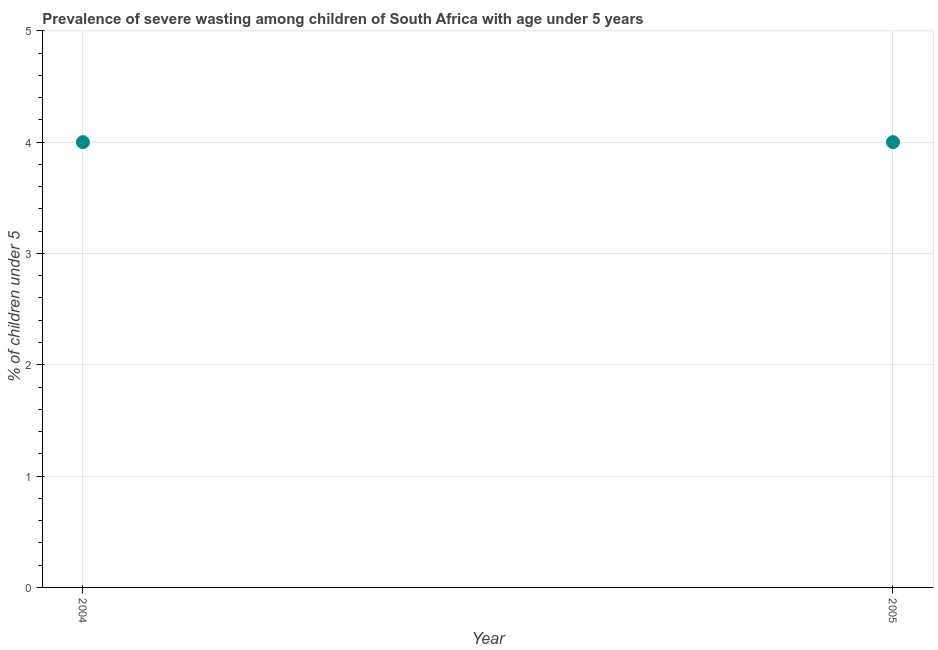What is the prevalence of severe wasting in 2005?
Keep it short and to the point. 4. Across all years, what is the maximum prevalence of severe wasting?
Your answer should be very brief. 4. Across all years, what is the minimum prevalence of severe wasting?
Provide a short and direct response. 4. In which year was the prevalence of severe wasting maximum?
Your response must be concise. 2004. What is the sum of the prevalence of severe wasting?
Provide a short and direct response. 8. What is the average prevalence of severe wasting per year?
Offer a very short reply. 4. What is the median prevalence of severe wasting?
Keep it short and to the point. 4. Do a majority of the years between 2005 and 2004 (inclusive) have prevalence of severe wasting greater than 1.6 %?
Give a very brief answer. No. What is the ratio of the prevalence of severe wasting in 2004 to that in 2005?
Provide a succinct answer. 1. Is the prevalence of severe wasting in 2004 less than that in 2005?
Ensure brevity in your answer.  No. In how many years, is the prevalence of severe wasting greater than the average prevalence of severe wasting taken over all years?
Provide a short and direct response. 0. Are the values on the major ticks of Y-axis written in scientific E-notation?
Provide a short and direct response. No. Does the graph contain grids?
Ensure brevity in your answer.  Yes. What is the title of the graph?
Make the answer very short. Prevalence of severe wasting among children of South Africa with age under 5 years. What is the label or title of the X-axis?
Your answer should be very brief. Year. What is the label or title of the Y-axis?
Make the answer very short.  % of children under 5. What is the  % of children under 5 in 2004?
Give a very brief answer. 4. 